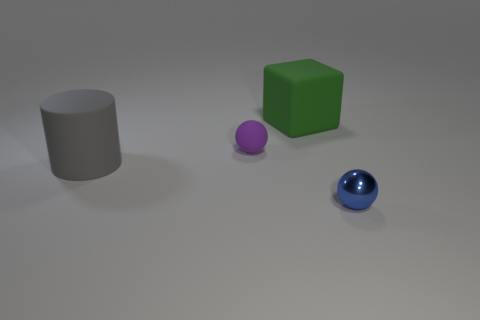What is the color of the thing that is to the right of the purple sphere and in front of the rubber block?
Your answer should be very brief. Blue. Is the number of objects greater than the number of purple rubber balls?
Offer a very short reply. Yes. Do the small object that is behind the blue metallic sphere and the small shiny thing have the same shape?
Your response must be concise. Yes. How many metal objects are cylinders or large cubes?
Offer a terse response. 0. Are there any large cylinders made of the same material as the purple sphere?
Your answer should be compact. Yes. What material is the gray cylinder?
Your answer should be compact. Rubber. What shape is the object that is right of the big rubber thing that is on the right side of the big thing that is on the left side of the green block?
Your answer should be compact. Sphere. Is the number of big rubber objects in front of the large green matte thing greater than the number of large shiny cylinders?
Offer a very short reply. Yes. There is a blue metal thing; is it the same shape as the tiny object that is on the left side of the green rubber block?
Keep it short and to the point. Yes. There is a thing to the left of the small ball that is behind the small blue shiny object; what number of large things are to the right of it?
Provide a short and direct response. 1. 